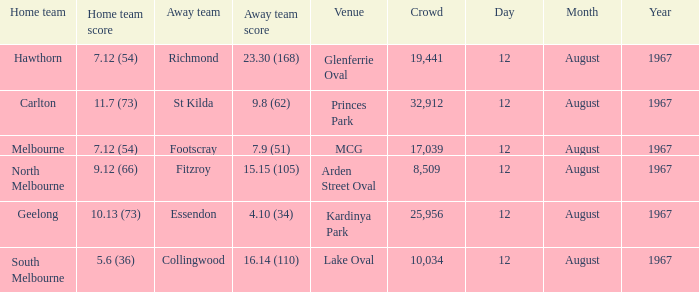What is the date of the game between Melbourne and Footscray? 12 August 1967. 